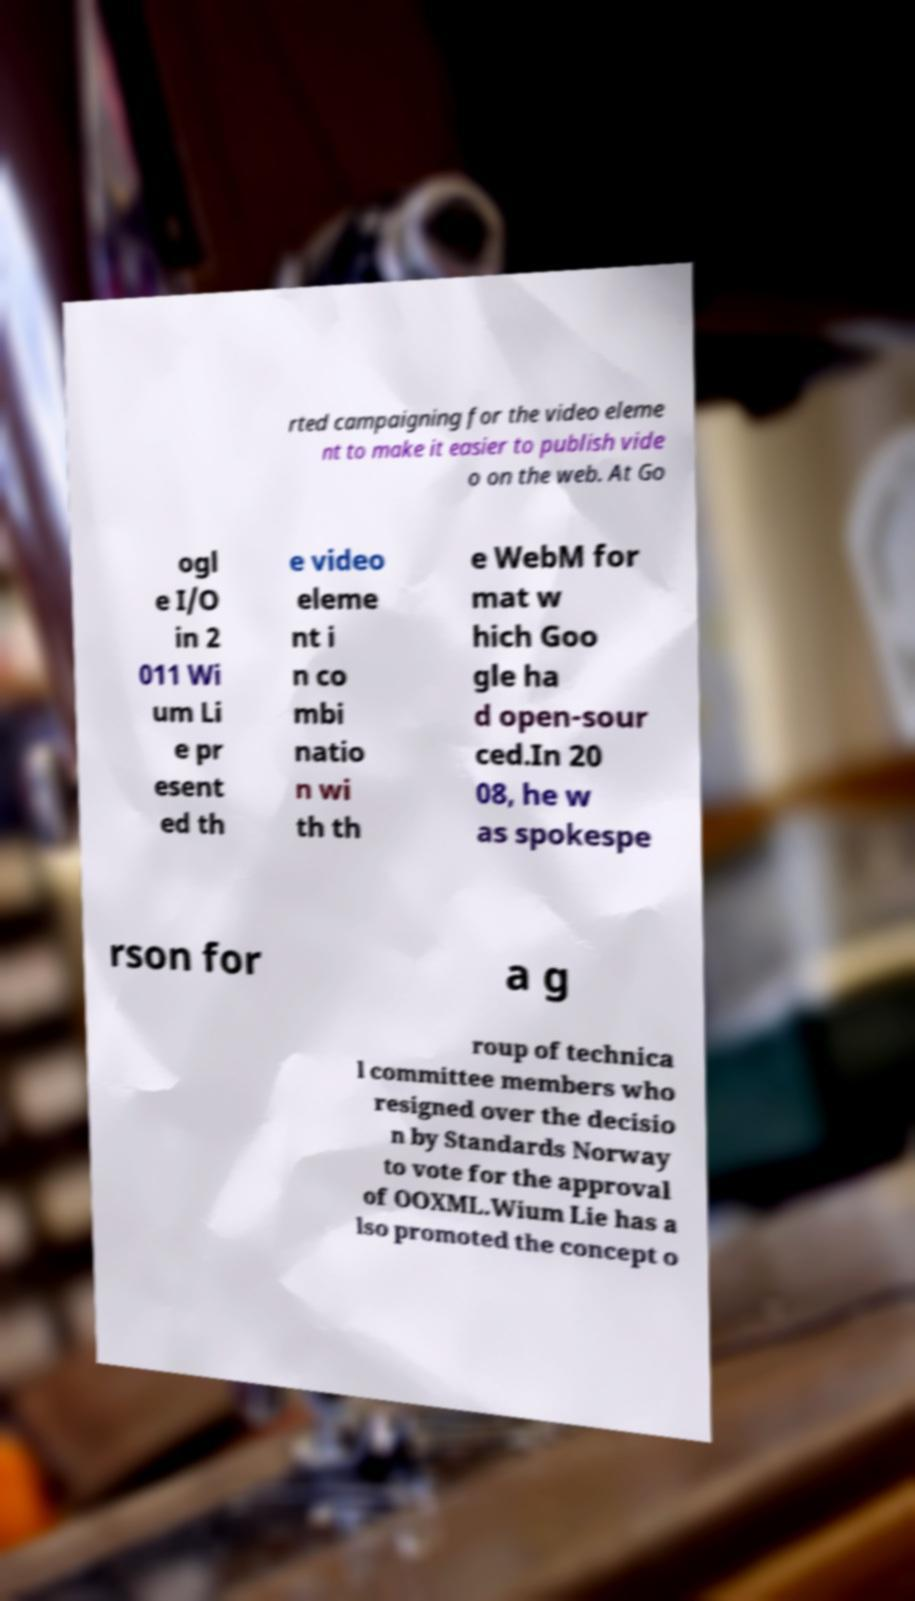What messages or text are displayed in this image? I need them in a readable, typed format. rted campaigning for the video eleme nt to make it easier to publish vide o on the web. At Go ogl e I/O in 2 011 Wi um Li e pr esent ed th e video eleme nt i n co mbi natio n wi th th e WebM for mat w hich Goo gle ha d open-sour ced.In 20 08, he w as spokespe rson for a g roup of technica l committee members who resigned over the decisio n by Standards Norway to vote for the approval of OOXML.Wium Lie has a lso promoted the concept o 